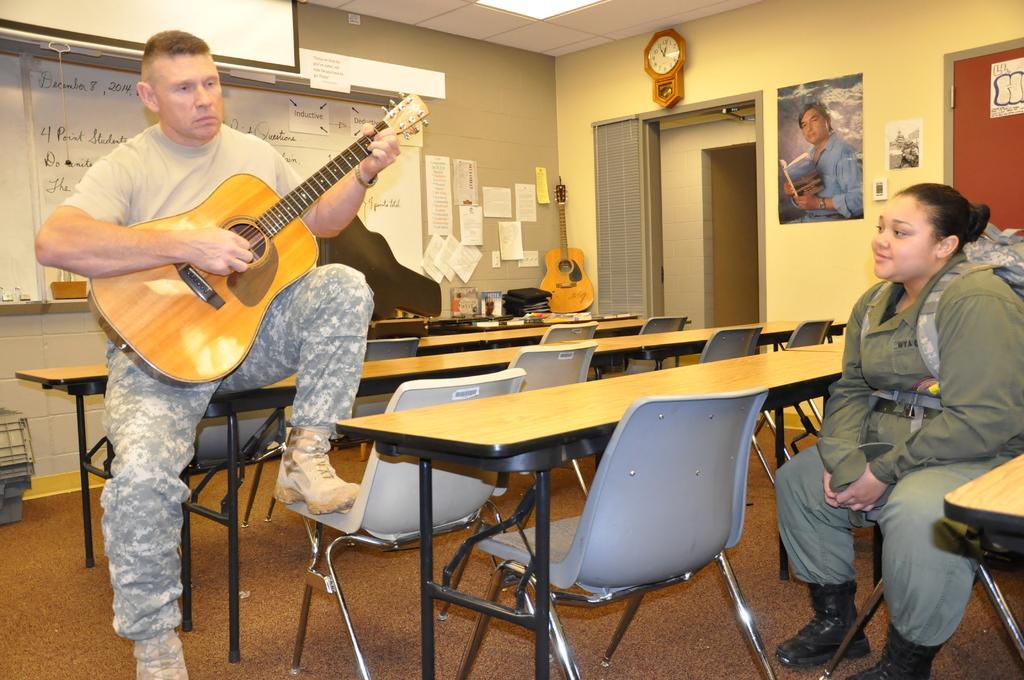Could you give a brief overview of what you see in this image? The picture consists of two people at the right corner one woman is sitting in a grey dress and carrying a bag and left corner one man is sitting on the bench with a guitar in his hands and infront of him there are tables and chairs and corner of the room there is another table on which a guitar, some books are placed on it behind that there is a big wall with white boards and papers attached to it, there is a door and a photo on it. 